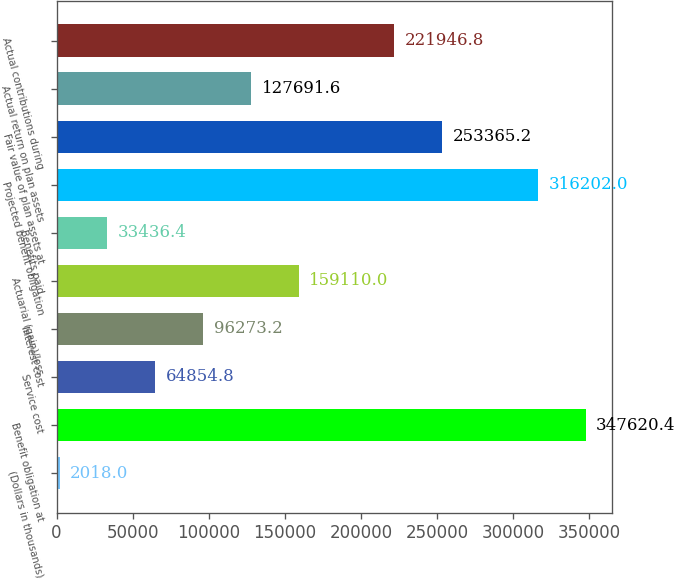Convert chart. <chart><loc_0><loc_0><loc_500><loc_500><bar_chart><fcel>(Dollars in thousands)<fcel>Benefit obligation at<fcel>Service cost<fcel>Interest cost<fcel>Actuarial (gain)/loss<fcel>Benefits paid<fcel>Projected benefit obligation<fcel>Fair value of plan assets at<fcel>Actual return on plan assets<fcel>Actual contributions during<nl><fcel>2018<fcel>347620<fcel>64854.8<fcel>96273.2<fcel>159110<fcel>33436.4<fcel>316202<fcel>253365<fcel>127692<fcel>221947<nl></chart> 